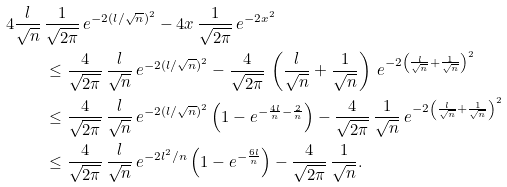<formula> <loc_0><loc_0><loc_500><loc_500>4 \frac { l } { \sqrt { n } } \, & \frac { 1 } { \sqrt { 2 \pi } } \, e ^ { - 2 ( l / \sqrt { n } ) ^ { 2 } } - 4 x \, \frac { 1 } { \sqrt { 2 \pi } } \, e ^ { - 2 x ^ { 2 } } \\ & \leq \frac { 4 } { \sqrt { 2 \pi } } \, \frac { l } { \sqrt { n } } \, e ^ { - 2 ( l / \sqrt { n } ) ^ { 2 } } - \frac { 4 } { \sqrt { 2 \pi } } \, \left ( \frac { l } { \sqrt { n } } + \frac { 1 } { \sqrt { n } } \right ) \, e ^ { - 2 \left ( \frac { l } { \sqrt { n } } + \frac { 1 } { \sqrt { n } } \right ) ^ { 2 } } \\ & \leq \frac { 4 } { \sqrt { 2 \pi } } \, \frac { l } { \sqrt { n } } \, e ^ { - 2 ( l / \sqrt { n } ) ^ { 2 } } \left ( 1 - e ^ { - \frac { 4 l } { n } - \frac { 2 } { n } } \right ) - \frac { 4 } { \sqrt { 2 \pi } } \, \frac { 1 } { \sqrt { n } } \, e ^ { - 2 \left ( \frac { l } { \sqrt { n } } + \frac { 1 } { \sqrt { n } } \right ) ^ { 2 } } \\ & \leq \frac { 4 } { \sqrt { 2 \pi } } \, \frac { l } { \sqrt { n } } \, e ^ { - 2 l ^ { 2 } / n } \left ( 1 - e ^ { - \frac { 6 l } { n } } \right ) - \frac { 4 } { \sqrt { 2 \pi } } \, \frac { 1 } { \sqrt { n } } .</formula> 